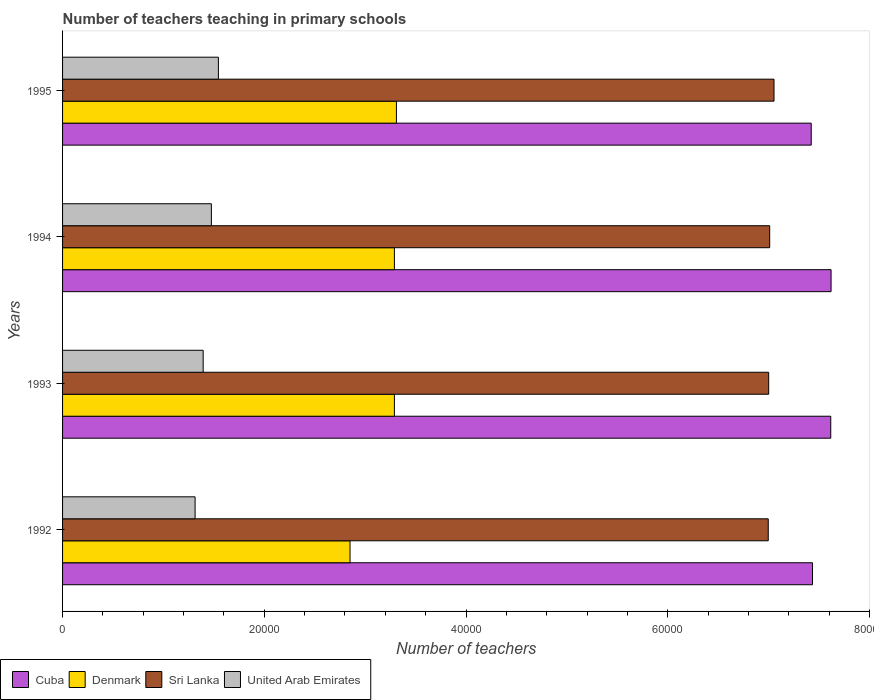How many groups of bars are there?
Offer a very short reply. 4. Are the number of bars per tick equal to the number of legend labels?
Provide a succinct answer. Yes. What is the label of the 1st group of bars from the top?
Ensure brevity in your answer.  1995. What is the number of teachers teaching in primary schools in Sri Lanka in 1994?
Your answer should be compact. 7.01e+04. Across all years, what is the maximum number of teachers teaching in primary schools in Sri Lanka?
Your response must be concise. 7.05e+04. Across all years, what is the minimum number of teachers teaching in primary schools in Denmark?
Give a very brief answer. 2.85e+04. In which year was the number of teachers teaching in primary schools in Cuba minimum?
Keep it short and to the point. 1995. What is the total number of teachers teaching in primary schools in Cuba in the graph?
Offer a terse response. 3.01e+05. What is the difference between the number of teachers teaching in primary schools in Sri Lanka in 1993 and that in 1994?
Provide a short and direct response. -100. What is the difference between the number of teachers teaching in primary schools in United Arab Emirates in 1992 and the number of teachers teaching in primary schools in Denmark in 1994?
Offer a very short reply. -1.98e+04. What is the average number of teachers teaching in primary schools in Sri Lanka per year?
Provide a short and direct response. 7.02e+04. In the year 1993, what is the difference between the number of teachers teaching in primary schools in Sri Lanka and number of teachers teaching in primary schools in United Arab Emirates?
Your response must be concise. 5.61e+04. What is the ratio of the number of teachers teaching in primary schools in Denmark in 1993 to that in 1995?
Offer a very short reply. 0.99. Is the difference between the number of teachers teaching in primary schools in Sri Lanka in 1992 and 1995 greater than the difference between the number of teachers teaching in primary schools in United Arab Emirates in 1992 and 1995?
Give a very brief answer. Yes. What is the difference between the highest and the second highest number of teachers teaching in primary schools in Sri Lanka?
Make the answer very short. 429. What is the difference between the highest and the lowest number of teachers teaching in primary schools in Cuba?
Offer a very short reply. 1968. Is the sum of the number of teachers teaching in primary schools in Cuba in 1993 and 1994 greater than the maximum number of teachers teaching in primary schools in United Arab Emirates across all years?
Your answer should be compact. Yes. Is it the case that in every year, the sum of the number of teachers teaching in primary schools in Sri Lanka and number of teachers teaching in primary schools in Denmark is greater than the sum of number of teachers teaching in primary schools in United Arab Emirates and number of teachers teaching in primary schools in Cuba?
Provide a succinct answer. Yes. What does the 2nd bar from the top in 1993 represents?
Offer a very short reply. Sri Lanka. What does the 1st bar from the bottom in 1994 represents?
Give a very brief answer. Cuba. How many bars are there?
Ensure brevity in your answer.  16. Does the graph contain grids?
Offer a very short reply. No. Where does the legend appear in the graph?
Your answer should be very brief. Bottom left. How many legend labels are there?
Your answer should be very brief. 4. How are the legend labels stacked?
Your answer should be compact. Horizontal. What is the title of the graph?
Ensure brevity in your answer.  Number of teachers teaching in primary schools. Does "Montenegro" appear as one of the legend labels in the graph?
Offer a very short reply. No. What is the label or title of the X-axis?
Keep it short and to the point. Number of teachers. What is the label or title of the Y-axis?
Offer a terse response. Years. What is the Number of teachers in Cuba in 1992?
Your response must be concise. 7.44e+04. What is the Number of teachers of Denmark in 1992?
Offer a very short reply. 2.85e+04. What is the Number of teachers of Sri Lanka in 1992?
Provide a succinct answer. 7.00e+04. What is the Number of teachers of United Arab Emirates in 1992?
Offer a very short reply. 1.31e+04. What is the Number of teachers of Cuba in 1993?
Provide a short and direct response. 7.62e+04. What is the Number of teachers in Denmark in 1993?
Provide a short and direct response. 3.29e+04. What is the Number of teachers in Sri Lanka in 1993?
Your response must be concise. 7.00e+04. What is the Number of teachers of United Arab Emirates in 1993?
Provide a short and direct response. 1.39e+04. What is the Number of teachers in Cuba in 1994?
Give a very brief answer. 7.62e+04. What is the Number of teachers in Denmark in 1994?
Provide a short and direct response. 3.29e+04. What is the Number of teachers of Sri Lanka in 1994?
Give a very brief answer. 7.01e+04. What is the Number of teachers in United Arab Emirates in 1994?
Your answer should be compact. 1.48e+04. What is the Number of teachers in Cuba in 1995?
Give a very brief answer. 7.42e+04. What is the Number of teachers of Denmark in 1995?
Keep it short and to the point. 3.31e+04. What is the Number of teachers in Sri Lanka in 1995?
Your answer should be very brief. 7.05e+04. What is the Number of teachers of United Arab Emirates in 1995?
Provide a succinct answer. 1.54e+04. Across all years, what is the maximum Number of teachers of Cuba?
Your answer should be compact. 7.62e+04. Across all years, what is the maximum Number of teachers of Denmark?
Your response must be concise. 3.31e+04. Across all years, what is the maximum Number of teachers in Sri Lanka?
Make the answer very short. 7.05e+04. Across all years, what is the maximum Number of teachers of United Arab Emirates?
Offer a very short reply. 1.54e+04. Across all years, what is the minimum Number of teachers of Cuba?
Keep it short and to the point. 7.42e+04. Across all years, what is the minimum Number of teachers in Denmark?
Provide a succinct answer. 2.85e+04. Across all years, what is the minimum Number of teachers of Sri Lanka?
Your answer should be compact. 7.00e+04. Across all years, what is the minimum Number of teachers in United Arab Emirates?
Your answer should be very brief. 1.31e+04. What is the total Number of teachers in Cuba in the graph?
Your answer should be compact. 3.01e+05. What is the total Number of teachers in Denmark in the graph?
Make the answer very short. 1.27e+05. What is the total Number of teachers of Sri Lanka in the graph?
Your answer should be compact. 2.81e+05. What is the total Number of teachers in United Arab Emirates in the graph?
Offer a very short reply. 5.73e+04. What is the difference between the Number of teachers in Cuba in 1992 and that in 1993?
Make the answer very short. -1807. What is the difference between the Number of teachers in Denmark in 1992 and that in 1993?
Offer a terse response. -4399. What is the difference between the Number of teachers in Sri Lanka in 1992 and that in 1993?
Offer a terse response. -43. What is the difference between the Number of teachers in United Arab Emirates in 1992 and that in 1993?
Offer a very short reply. -801. What is the difference between the Number of teachers in Cuba in 1992 and that in 1994?
Offer a very short reply. -1839. What is the difference between the Number of teachers in Denmark in 1992 and that in 1994?
Provide a short and direct response. -4399. What is the difference between the Number of teachers of Sri Lanka in 1992 and that in 1994?
Your answer should be very brief. -143. What is the difference between the Number of teachers in United Arab Emirates in 1992 and that in 1994?
Ensure brevity in your answer.  -1615. What is the difference between the Number of teachers of Cuba in 1992 and that in 1995?
Provide a succinct answer. 129. What is the difference between the Number of teachers of Denmark in 1992 and that in 1995?
Provide a short and direct response. -4599. What is the difference between the Number of teachers of Sri Lanka in 1992 and that in 1995?
Offer a very short reply. -572. What is the difference between the Number of teachers of United Arab Emirates in 1992 and that in 1995?
Keep it short and to the point. -2310. What is the difference between the Number of teachers of Cuba in 1993 and that in 1994?
Give a very brief answer. -32. What is the difference between the Number of teachers of Sri Lanka in 1993 and that in 1994?
Offer a terse response. -100. What is the difference between the Number of teachers in United Arab Emirates in 1993 and that in 1994?
Your response must be concise. -814. What is the difference between the Number of teachers in Cuba in 1993 and that in 1995?
Make the answer very short. 1936. What is the difference between the Number of teachers of Denmark in 1993 and that in 1995?
Keep it short and to the point. -200. What is the difference between the Number of teachers of Sri Lanka in 1993 and that in 1995?
Provide a short and direct response. -529. What is the difference between the Number of teachers of United Arab Emirates in 1993 and that in 1995?
Offer a terse response. -1509. What is the difference between the Number of teachers of Cuba in 1994 and that in 1995?
Keep it short and to the point. 1968. What is the difference between the Number of teachers in Denmark in 1994 and that in 1995?
Make the answer very short. -200. What is the difference between the Number of teachers of Sri Lanka in 1994 and that in 1995?
Ensure brevity in your answer.  -429. What is the difference between the Number of teachers of United Arab Emirates in 1994 and that in 1995?
Your answer should be compact. -695. What is the difference between the Number of teachers of Cuba in 1992 and the Number of teachers of Denmark in 1993?
Ensure brevity in your answer.  4.15e+04. What is the difference between the Number of teachers in Cuba in 1992 and the Number of teachers in Sri Lanka in 1993?
Your answer should be very brief. 4346. What is the difference between the Number of teachers in Cuba in 1992 and the Number of teachers in United Arab Emirates in 1993?
Provide a short and direct response. 6.04e+04. What is the difference between the Number of teachers of Denmark in 1992 and the Number of teachers of Sri Lanka in 1993?
Offer a very short reply. -4.15e+04. What is the difference between the Number of teachers of Denmark in 1992 and the Number of teachers of United Arab Emirates in 1993?
Keep it short and to the point. 1.46e+04. What is the difference between the Number of teachers of Sri Lanka in 1992 and the Number of teachers of United Arab Emirates in 1993?
Keep it short and to the point. 5.60e+04. What is the difference between the Number of teachers of Cuba in 1992 and the Number of teachers of Denmark in 1994?
Your answer should be compact. 4.15e+04. What is the difference between the Number of teachers of Cuba in 1992 and the Number of teachers of Sri Lanka in 1994?
Your response must be concise. 4246. What is the difference between the Number of teachers of Cuba in 1992 and the Number of teachers of United Arab Emirates in 1994?
Provide a short and direct response. 5.96e+04. What is the difference between the Number of teachers of Denmark in 1992 and the Number of teachers of Sri Lanka in 1994?
Ensure brevity in your answer.  -4.16e+04. What is the difference between the Number of teachers of Denmark in 1992 and the Number of teachers of United Arab Emirates in 1994?
Offer a very short reply. 1.37e+04. What is the difference between the Number of teachers in Sri Lanka in 1992 and the Number of teachers in United Arab Emirates in 1994?
Your answer should be very brief. 5.52e+04. What is the difference between the Number of teachers of Cuba in 1992 and the Number of teachers of Denmark in 1995?
Provide a short and direct response. 4.13e+04. What is the difference between the Number of teachers of Cuba in 1992 and the Number of teachers of Sri Lanka in 1995?
Your response must be concise. 3817. What is the difference between the Number of teachers of Cuba in 1992 and the Number of teachers of United Arab Emirates in 1995?
Provide a short and direct response. 5.89e+04. What is the difference between the Number of teachers in Denmark in 1992 and the Number of teachers in Sri Lanka in 1995?
Keep it short and to the point. -4.20e+04. What is the difference between the Number of teachers of Denmark in 1992 and the Number of teachers of United Arab Emirates in 1995?
Ensure brevity in your answer.  1.31e+04. What is the difference between the Number of teachers in Sri Lanka in 1992 and the Number of teachers in United Arab Emirates in 1995?
Offer a terse response. 5.45e+04. What is the difference between the Number of teachers in Cuba in 1993 and the Number of teachers in Denmark in 1994?
Your response must be concise. 4.33e+04. What is the difference between the Number of teachers of Cuba in 1993 and the Number of teachers of Sri Lanka in 1994?
Offer a terse response. 6053. What is the difference between the Number of teachers of Cuba in 1993 and the Number of teachers of United Arab Emirates in 1994?
Provide a succinct answer. 6.14e+04. What is the difference between the Number of teachers of Denmark in 1993 and the Number of teachers of Sri Lanka in 1994?
Your response must be concise. -3.72e+04. What is the difference between the Number of teachers in Denmark in 1993 and the Number of teachers in United Arab Emirates in 1994?
Make the answer very short. 1.81e+04. What is the difference between the Number of teachers in Sri Lanka in 1993 and the Number of teachers in United Arab Emirates in 1994?
Offer a terse response. 5.53e+04. What is the difference between the Number of teachers of Cuba in 1993 and the Number of teachers of Denmark in 1995?
Offer a very short reply. 4.31e+04. What is the difference between the Number of teachers of Cuba in 1993 and the Number of teachers of Sri Lanka in 1995?
Offer a very short reply. 5624. What is the difference between the Number of teachers in Cuba in 1993 and the Number of teachers in United Arab Emirates in 1995?
Ensure brevity in your answer.  6.07e+04. What is the difference between the Number of teachers of Denmark in 1993 and the Number of teachers of Sri Lanka in 1995?
Make the answer very short. -3.76e+04. What is the difference between the Number of teachers in Denmark in 1993 and the Number of teachers in United Arab Emirates in 1995?
Offer a terse response. 1.75e+04. What is the difference between the Number of teachers of Sri Lanka in 1993 and the Number of teachers of United Arab Emirates in 1995?
Offer a terse response. 5.46e+04. What is the difference between the Number of teachers of Cuba in 1994 and the Number of teachers of Denmark in 1995?
Keep it short and to the point. 4.31e+04. What is the difference between the Number of teachers in Cuba in 1994 and the Number of teachers in Sri Lanka in 1995?
Offer a terse response. 5656. What is the difference between the Number of teachers of Cuba in 1994 and the Number of teachers of United Arab Emirates in 1995?
Ensure brevity in your answer.  6.07e+04. What is the difference between the Number of teachers in Denmark in 1994 and the Number of teachers in Sri Lanka in 1995?
Provide a succinct answer. -3.76e+04. What is the difference between the Number of teachers in Denmark in 1994 and the Number of teachers in United Arab Emirates in 1995?
Offer a very short reply. 1.75e+04. What is the difference between the Number of teachers in Sri Lanka in 1994 and the Number of teachers in United Arab Emirates in 1995?
Offer a very short reply. 5.47e+04. What is the average Number of teachers of Cuba per year?
Keep it short and to the point. 7.52e+04. What is the average Number of teachers in Denmark per year?
Give a very brief answer. 3.19e+04. What is the average Number of teachers of Sri Lanka per year?
Your answer should be compact. 7.02e+04. What is the average Number of teachers in United Arab Emirates per year?
Offer a terse response. 1.43e+04. In the year 1992, what is the difference between the Number of teachers of Cuba and Number of teachers of Denmark?
Offer a very short reply. 4.59e+04. In the year 1992, what is the difference between the Number of teachers of Cuba and Number of teachers of Sri Lanka?
Your answer should be very brief. 4389. In the year 1992, what is the difference between the Number of teachers of Cuba and Number of teachers of United Arab Emirates?
Your response must be concise. 6.12e+04. In the year 1992, what is the difference between the Number of teachers in Denmark and Number of teachers in Sri Lanka?
Your answer should be compact. -4.15e+04. In the year 1992, what is the difference between the Number of teachers in Denmark and Number of teachers in United Arab Emirates?
Make the answer very short. 1.54e+04. In the year 1992, what is the difference between the Number of teachers in Sri Lanka and Number of teachers in United Arab Emirates?
Give a very brief answer. 5.68e+04. In the year 1993, what is the difference between the Number of teachers in Cuba and Number of teachers in Denmark?
Offer a very short reply. 4.33e+04. In the year 1993, what is the difference between the Number of teachers in Cuba and Number of teachers in Sri Lanka?
Give a very brief answer. 6153. In the year 1993, what is the difference between the Number of teachers of Cuba and Number of teachers of United Arab Emirates?
Give a very brief answer. 6.22e+04. In the year 1993, what is the difference between the Number of teachers of Denmark and Number of teachers of Sri Lanka?
Your answer should be compact. -3.71e+04. In the year 1993, what is the difference between the Number of teachers of Denmark and Number of teachers of United Arab Emirates?
Make the answer very short. 1.90e+04. In the year 1993, what is the difference between the Number of teachers in Sri Lanka and Number of teachers in United Arab Emirates?
Offer a very short reply. 5.61e+04. In the year 1994, what is the difference between the Number of teachers in Cuba and Number of teachers in Denmark?
Offer a terse response. 4.33e+04. In the year 1994, what is the difference between the Number of teachers of Cuba and Number of teachers of Sri Lanka?
Provide a short and direct response. 6085. In the year 1994, what is the difference between the Number of teachers of Cuba and Number of teachers of United Arab Emirates?
Your answer should be compact. 6.14e+04. In the year 1994, what is the difference between the Number of teachers of Denmark and Number of teachers of Sri Lanka?
Provide a short and direct response. -3.72e+04. In the year 1994, what is the difference between the Number of teachers of Denmark and Number of teachers of United Arab Emirates?
Provide a succinct answer. 1.81e+04. In the year 1994, what is the difference between the Number of teachers in Sri Lanka and Number of teachers in United Arab Emirates?
Your response must be concise. 5.54e+04. In the year 1995, what is the difference between the Number of teachers in Cuba and Number of teachers in Denmark?
Provide a succinct answer. 4.11e+04. In the year 1995, what is the difference between the Number of teachers of Cuba and Number of teachers of Sri Lanka?
Offer a very short reply. 3688. In the year 1995, what is the difference between the Number of teachers in Cuba and Number of teachers in United Arab Emirates?
Keep it short and to the point. 5.88e+04. In the year 1995, what is the difference between the Number of teachers in Denmark and Number of teachers in Sri Lanka?
Provide a succinct answer. -3.74e+04. In the year 1995, what is the difference between the Number of teachers of Denmark and Number of teachers of United Arab Emirates?
Provide a succinct answer. 1.77e+04. In the year 1995, what is the difference between the Number of teachers in Sri Lanka and Number of teachers in United Arab Emirates?
Provide a succinct answer. 5.51e+04. What is the ratio of the Number of teachers in Cuba in 1992 to that in 1993?
Offer a very short reply. 0.98. What is the ratio of the Number of teachers of Denmark in 1992 to that in 1993?
Give a very brief answer. 0.87. What is the ratio of the Number of teachers of United Arab Emirates in 1992 to that in 1993?
Provide a short and direct response. 0.94. What is the ratio of the Number of teachers of Cuba in 1992 to that in 1994?
Give a very brief answer. 0.98. What is the ratio of the Number of teachers in Denmark in 1992 to that in 1994?
Your response must be concise. 0.87. What is the ratio of the Number of teachers in Sri Lanka in 1992 to that in 1994?
Your response must be concise. 1. What is the ratio of the Number of teachers in United Arab Emirates in 1992 to that in 1994?
Keep it short and to the point. 0.89. What is the ratio of the Number of teachers of Denmark in 1992 to that in 1995?
Give a very brief answer. 0.86. What is the ratio of the Number of teachers of Sri Lanka in 1992 to that in 1995?
Provide a succinct answer. 0.99. What is the ratio of the Number of teachers of United Arab Emirates in 1992 to that in 1995?
Make the answer very short. 0.85. What is the ratio of the Number of teachers of Cuba in 1993 to that in 1994?
Offer a very short reply. 1. What is the ratio of the Number of teachers in Denmark in 1993 to that in 1994?
Make the answer very short. 1. What is the ratio of the Number of teachers of United Arab Emirates in 1993 to that in 1994?
Your response must be concise. 0.94. What is the ratio of the Number of teachers in Cuba in 1993 to that in 1995?
Your response must be concise. 1.03. What is the ratio of the Number of teachers of Denmark in 1993 to that in 1995?
Your response must be concise. 0.99. What is the ratio of the Number of teachers in United Arab Emirates in 1993 to that in 1995?
Provide a short and direct response. 0.9. What is the ratio of the Number of teachers in Cuba in 1994 to that in 1995?
Your answer should be compact. 1.03. What is the ratio of the Number of teachers in Denmark in 1994 to that in 1995?
Give a very brief answer. 0.99. What is the ratio of the Number of teachers in Sri Lanka in 1994 to that in 1995?
Offer a terse response. 0.99. What is the ratio of the Number of teachers in United Arab Emirates in 1994 to that in 1995?
Your response must be concise. 0.95. What is the difference between the highest and the second highest Number of teachers of Denmark?
Keep it short and to the point. 200. What is the difference between the highest and the second highest Number of teachers in Sri Lanka?
Your answer should be very brief. 429. What is the difference between the highest and the second highest Number of teachers of United Arab Emirates?
Ensure brevity in your answer.  695. What is the difference between the highest and the lowest Number of teachers in Cuba?
Offer a very short reply. 1968. What is the difference between the highest and the lowest Number of teachers of Denmark?
Offer a very short reply. 4599. What is the difference between the highest and the lowest Number of teachers in Sri Lanka?
Your answer should be compact. 572. What is the difference between the highest and the lowest Number of teachers of United Arab Emirates?
Keep it short and to the point. 2310. 